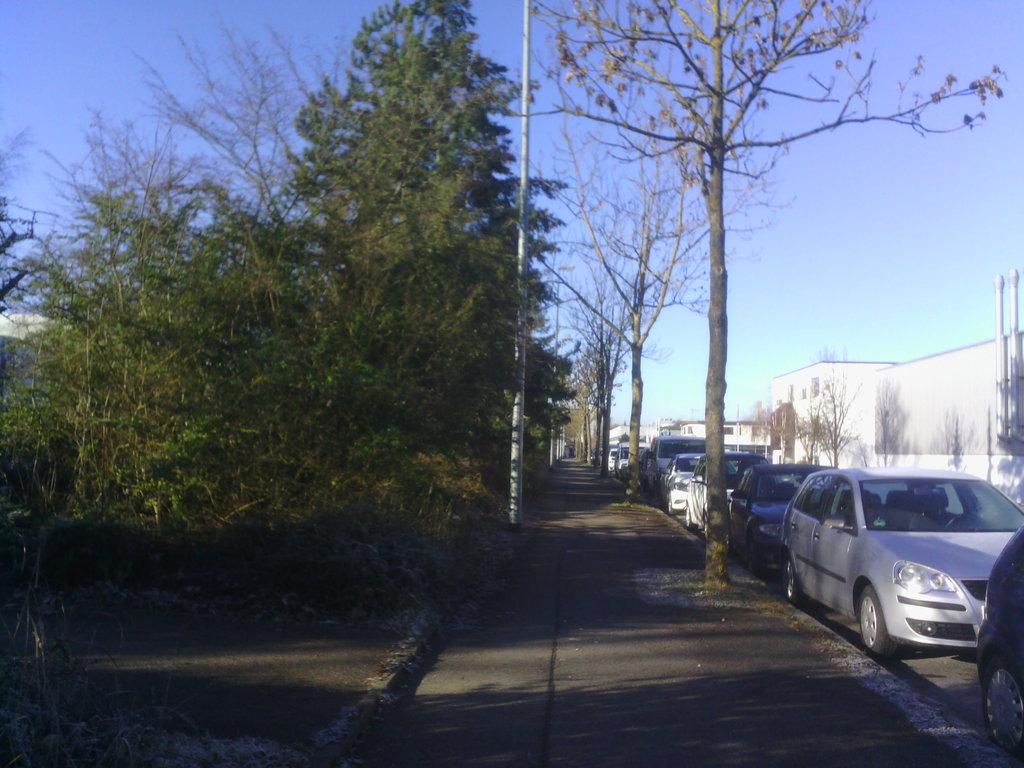What type of path is visible in the image? There is a walkway in the image. What natural elements can be seen in the image? There are trees in the image. What object is present near the walkway? There is a pole in the image. What type of transportation is visible in the image? There are vehicles on the road in the image. What type of structures are located at the right side of the image? There are buildings at the right side of the image. What scientific discovery is being made in the image? There is no scientific discovery being made in the image. What is the condition of the goose in the image? There is no goose present in the image. 